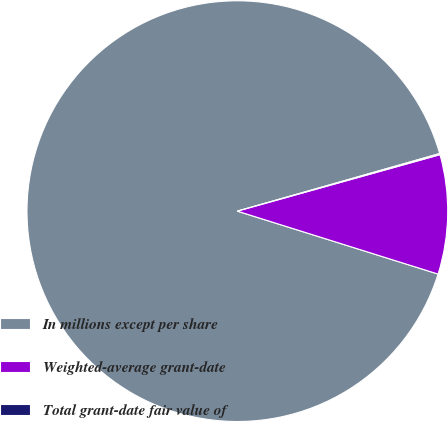Convert chart. <chart><loc_0><loc_0><loc_500><loc_500><pie_chart><fcel>In millions except per share<fcel>Weighted-average grant-date<fcel>Total grant-date fair value of<nl><fcel>90.75%<fcel>9.16%<fcel>0.09%<nl></chart> 